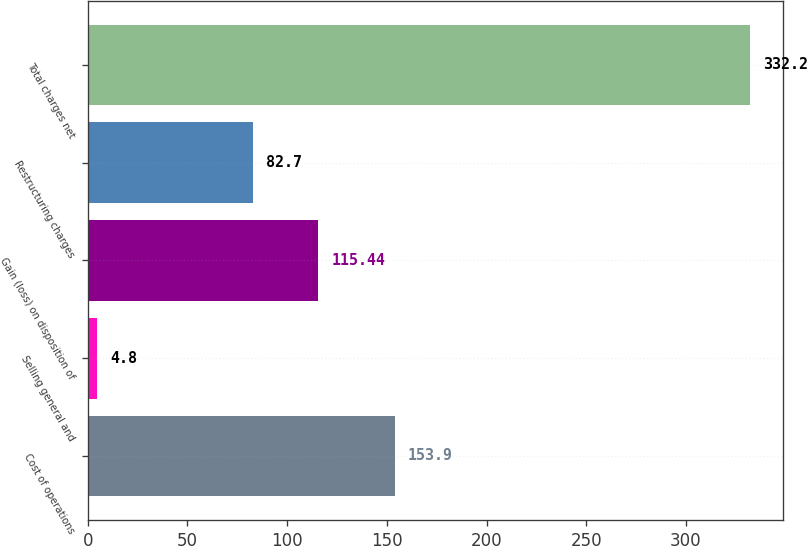<chart> <loc_0><loc_0><loc_500><loc_500><bar_chart><fcel>Cost of operations<fcel>Selling general and<fcel>Gain (loss) on disposition of<fcel>Restructuring charges<fcel>Total charges net<nl><fcel>153.9<fcel>4.8<fcel>115.44<fcel>82.7<fcel>332.2<nl></chart> 